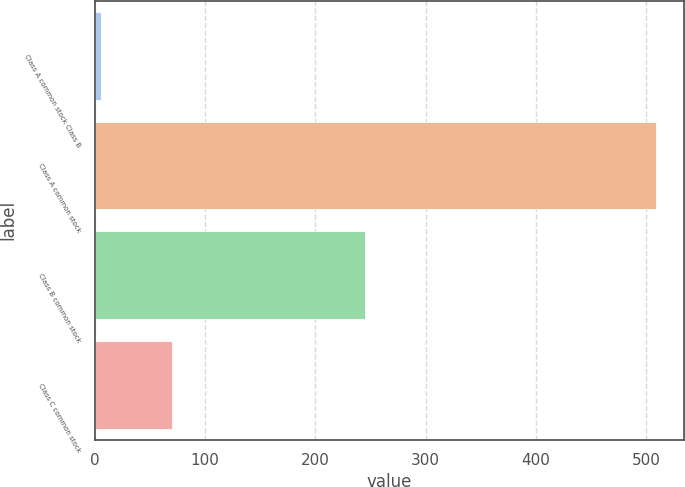Convert chart to OTSL. <chart><loc_0><loc_0><loc_500><loc_500><bar_chart><fcel>Class A common stock Class B<fcel>Class A common stock<fcel>Class B common stock<fcel>Class C common stock<nl><fcel>5.18<fcel>509<fcel>245<fcel>70<nl></chart> 